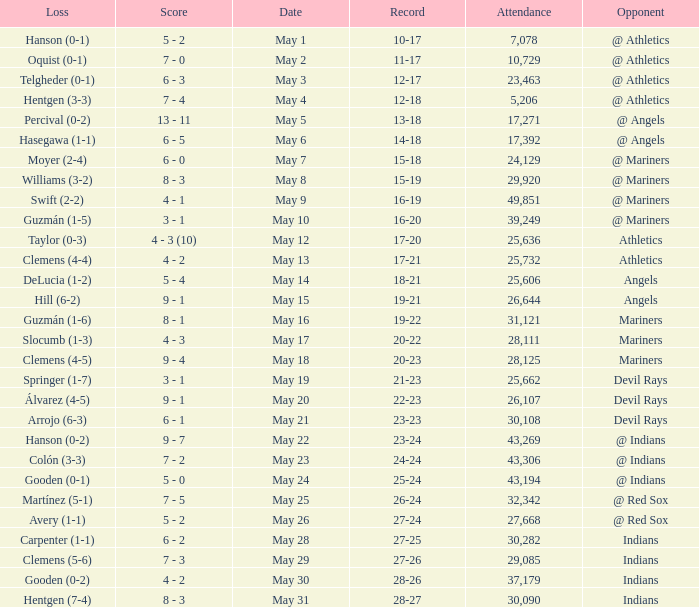Which person or team faced a loss on may 31? Hentgen (7-4). 